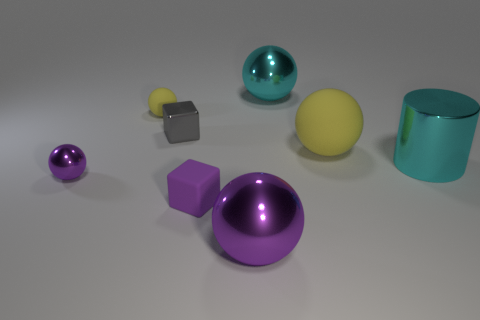Subtract all gray cylinders. Subtract all cyan cubes. How many cylinders are left? 1 Add 2 large metallic cylinders. How many objects exist? 10 Subtract all spheres. How many objects are left? 3 Add 8 green rubber objects. How many green rubber objects exist? 8 Subtract 0 gray cylinders. How many objects are left? 8 Subtract all green metal balls. Subtract all tiny metal cubes. How many objects are left? 7 Add 4 big cyan metallic things. How many big cyan metallic things are left? 6 